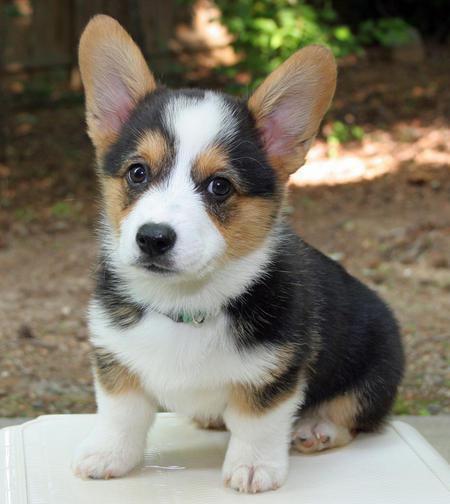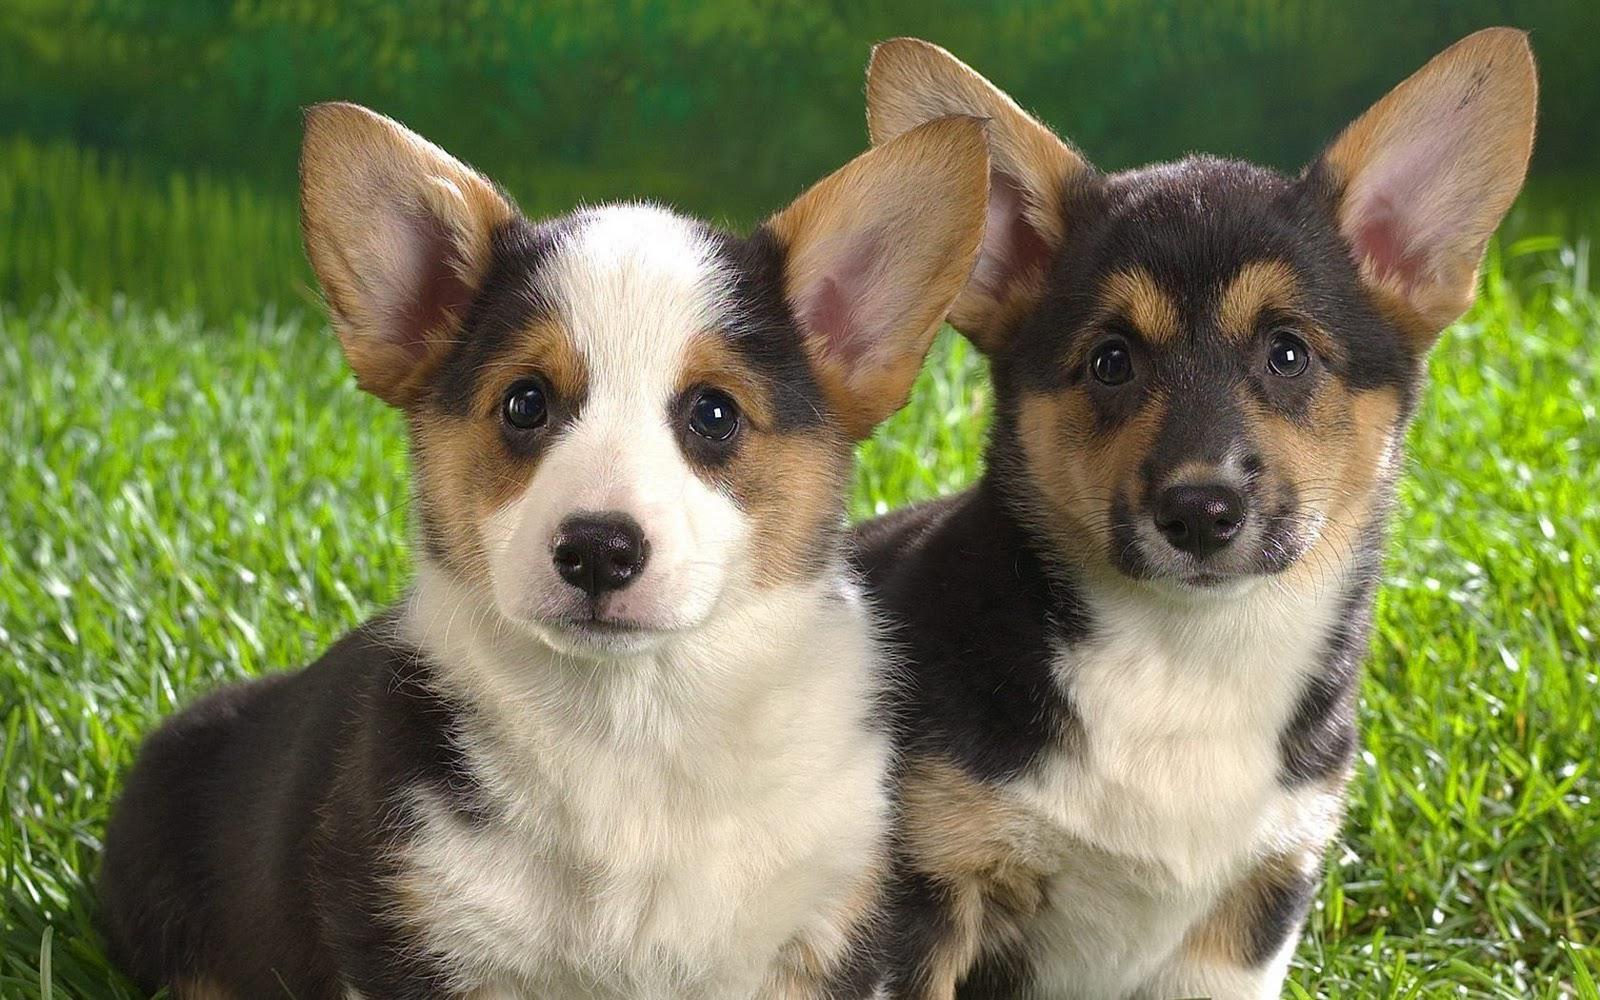The first image is the image on the left, the second image is the image on the right. For the images displayed, is the sentence "the dog in the image on the right is in side profile" factually correct? Answer yes or no. No. 